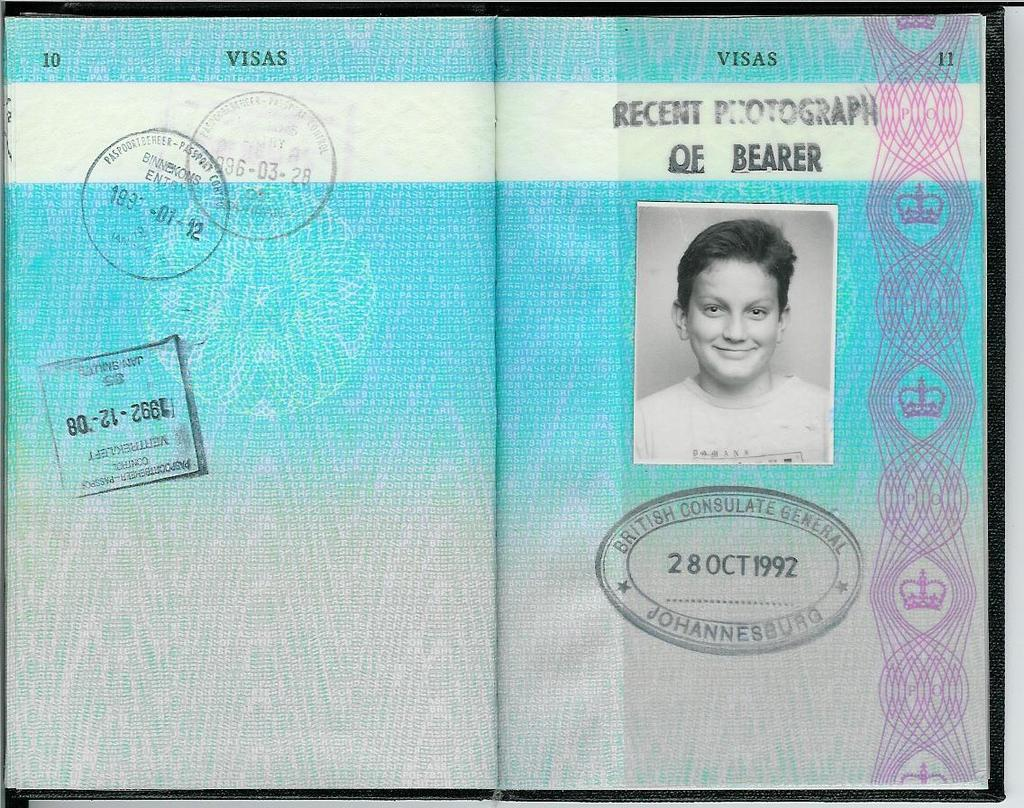What is the main object in the image? There is a book in the image. What can be seen on the cover of the book? The book has a photo of a person on it. Are there any additional features on the book? Yes, there are stamps on the book. What else can be found on the book? There is text on the book. How many fingers can be seen on the person in the photo on the book? There is no way to determine the number of fingers visible on the person in the photo on the book, as the image does not provide enough detail to make that determination. 